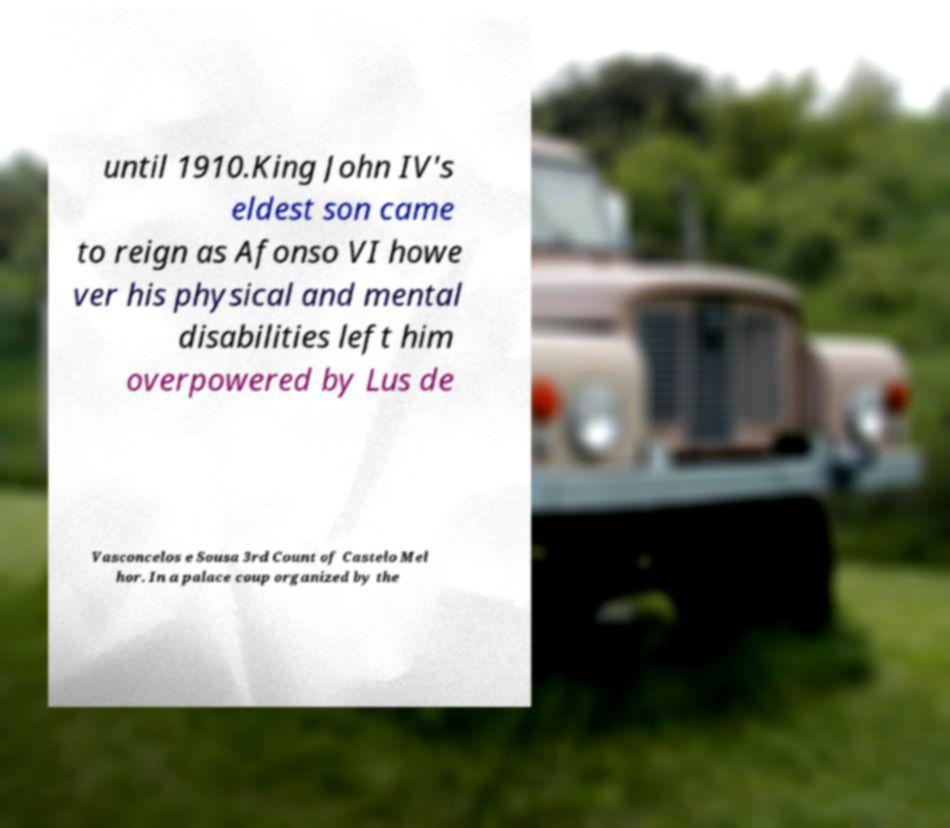There's text embedded in this image that I need extracted. Can you transcribe it verbatim? until 1910.King John IV's eldest son came to reign as Afonso VI howe ver his physical and mental disabilities left him overpowered by Lus de Vasconcelos e Sousa 3rd Count of Castelo Mel hor. In a palace coup organized by the 